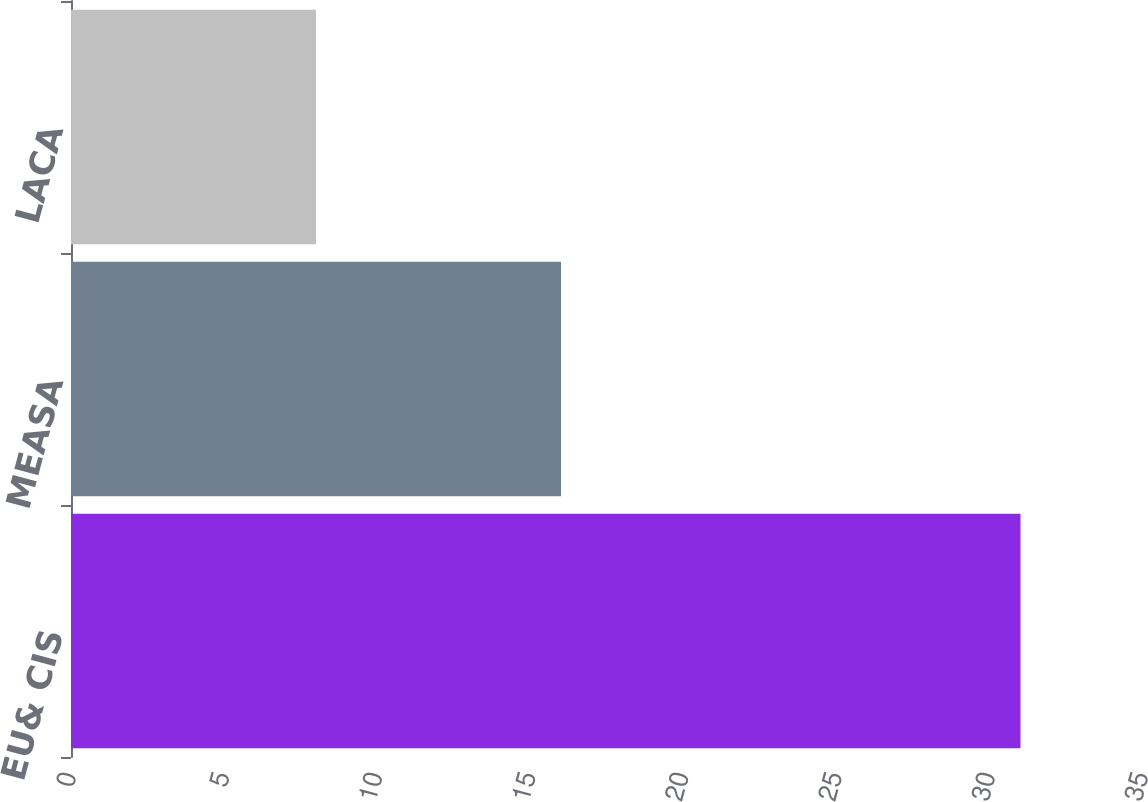<chart> <loc_0><loc_0><loc_500><loc_500><bar_chart><fcel>EU& CIS<fcel>MEASA<fcel>LACA<nl><fcel>31<fcel>16<fcel>8<nl></chart> 